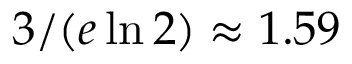<formula> <loc_0><loc_0><loc_500><loc_500>3 / ( e \ln 2 ) \approx 1 . 5 9</formula> 